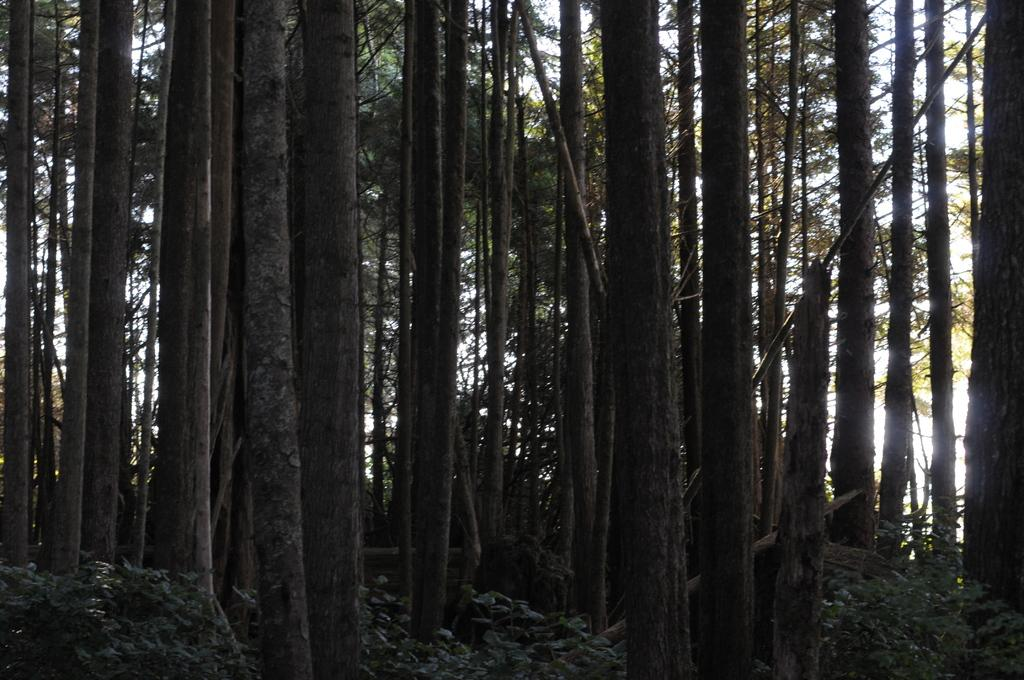What type of vegetation can be seen in the image? There is a group of trees in the image. What else can be found at the bottom of the image? There are plants at the bottom of the image. What type of steel structure can be seen in the image? There is no steel structure present in the image; it features a group of trees and plants. What type of plough is being used to cultivate the plants in the image? There is no plough visible in the image, as it only shows a group of trees and plants. 